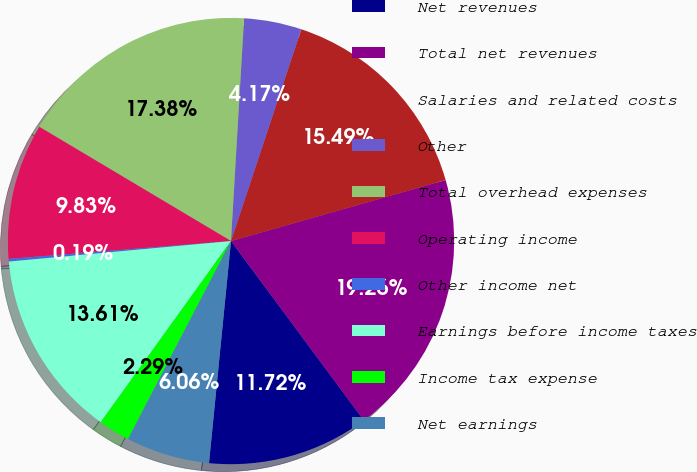Convert chart to OTSL. <chart><loc_0><loc_0><loc_500><loc_500><pie_chart><fcel>Net revenues<fcel>Total net revenues<fcel>Salaries and related costs<fcel>Other<fcel>Total overhead expenses<fcel>Operating income<fcel>Other income net<fcel>Earnings before income taxes<fcel>Income tax expense<fcel>Net earnings<nl><fcel>11.72%<fcel>19.26%<fcel>15.49%<fcel>4.17%<fcel>17.38%<fcel>9.83%<fcel>0.19%<fcel>13.61%<fcel>2.29%<fcel>6.06%<nl></chart> 